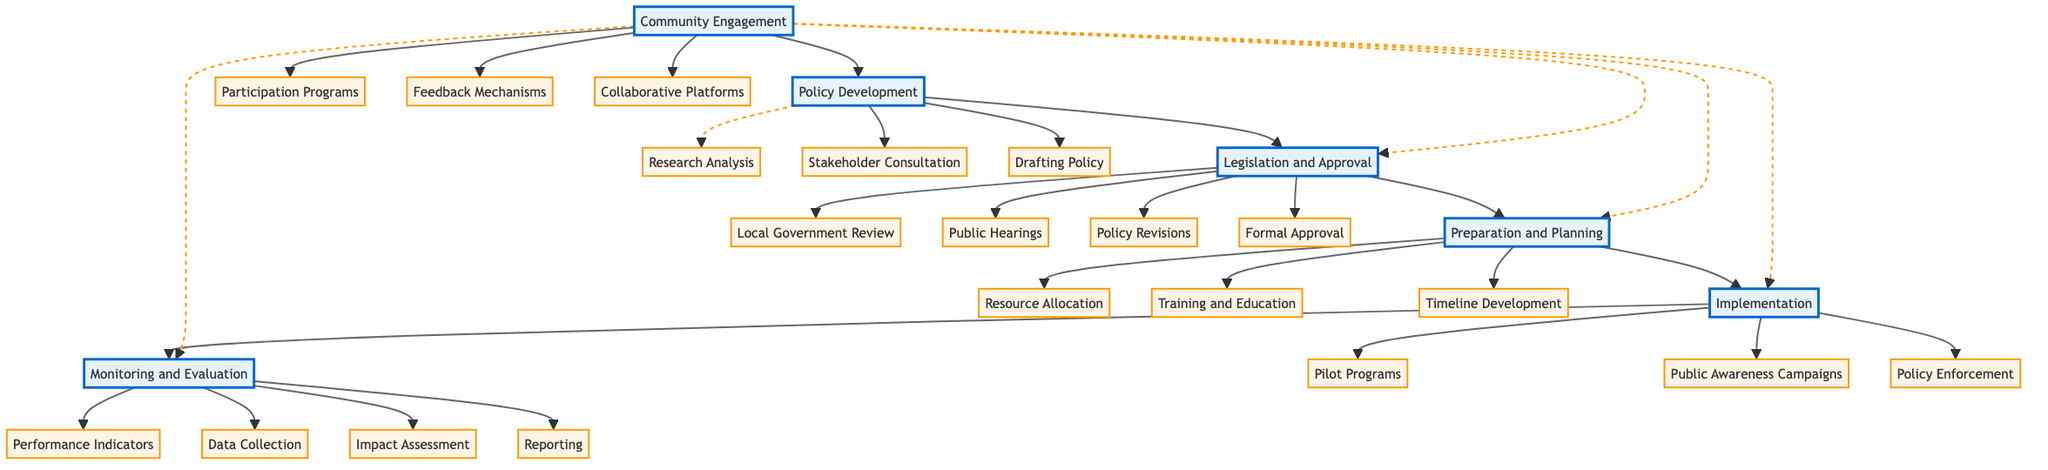What is the first step in the Climate Policy Implementation Process? According to the diagram, the first node under the main process is "Policy Development," which emphasizes starting with research analysis, stakeholder consultation, and drafting policy.
Answer: Policy Development How many sub-processes are there under "Legislation and Approval"? By examining the diagram, "Legislation and Approval" has four sub-processes: Local Government Review, Public Hearings, Policy Revisions, and Formal Approval.
Answer: Four What connects "Monitoring and Evaluation" to "Implementation"? The flow from "Implementation" to "Monitoring and Evaluation" is represented by a direct edge in the diagram, indicating that monitoring follows implementation.
Answer: Direct connection Which sub-process involves community input? The sub-process that focuses on community input is "Public Hearings" under the "Legislation and Approval" section, designed to gather feedback from the public.
Answer: Public Hearings What is a key outcome of the "Preparation and Planning" stage? The diagram shows "Resource Allocation," "Training and Education," and "Timeline Development" as critical outcomes of this stage, which are preparatory measures for successful implementation.
Answer: Resource Allocation Which main process is supported by "Participation Programs"? The diagram indicates that "Participation Programs" is part of the "Community Engagement" process, which feeds into all main processes as a supportive mechanism.
Answer: Community Engagement What follows the "Drafting Policy" step? The diagram illustrates that "Drafting Policy" is directly followed by "Legislation and Approval," meaning that once drafting is completed, the policy moves on to legislative scrutiny.
Answer: Legislation and Approval How does "Community Engagement" influence other processes? The diagram shows that "Community Engagement" creates connections with all main processes, enhancing their effectiveness through stakeholder involvement across the policy framework.
Answer: It influences all processes What is the function of "Impact Assessment" in the process? "Impact Assessment" serves as a final evaluation tool within the "Monitoring and Evaluation" phase, allowing for a comprehensive review of the policy's effects on environmental, social, and economic factors.
Answer: Evaluation tool 